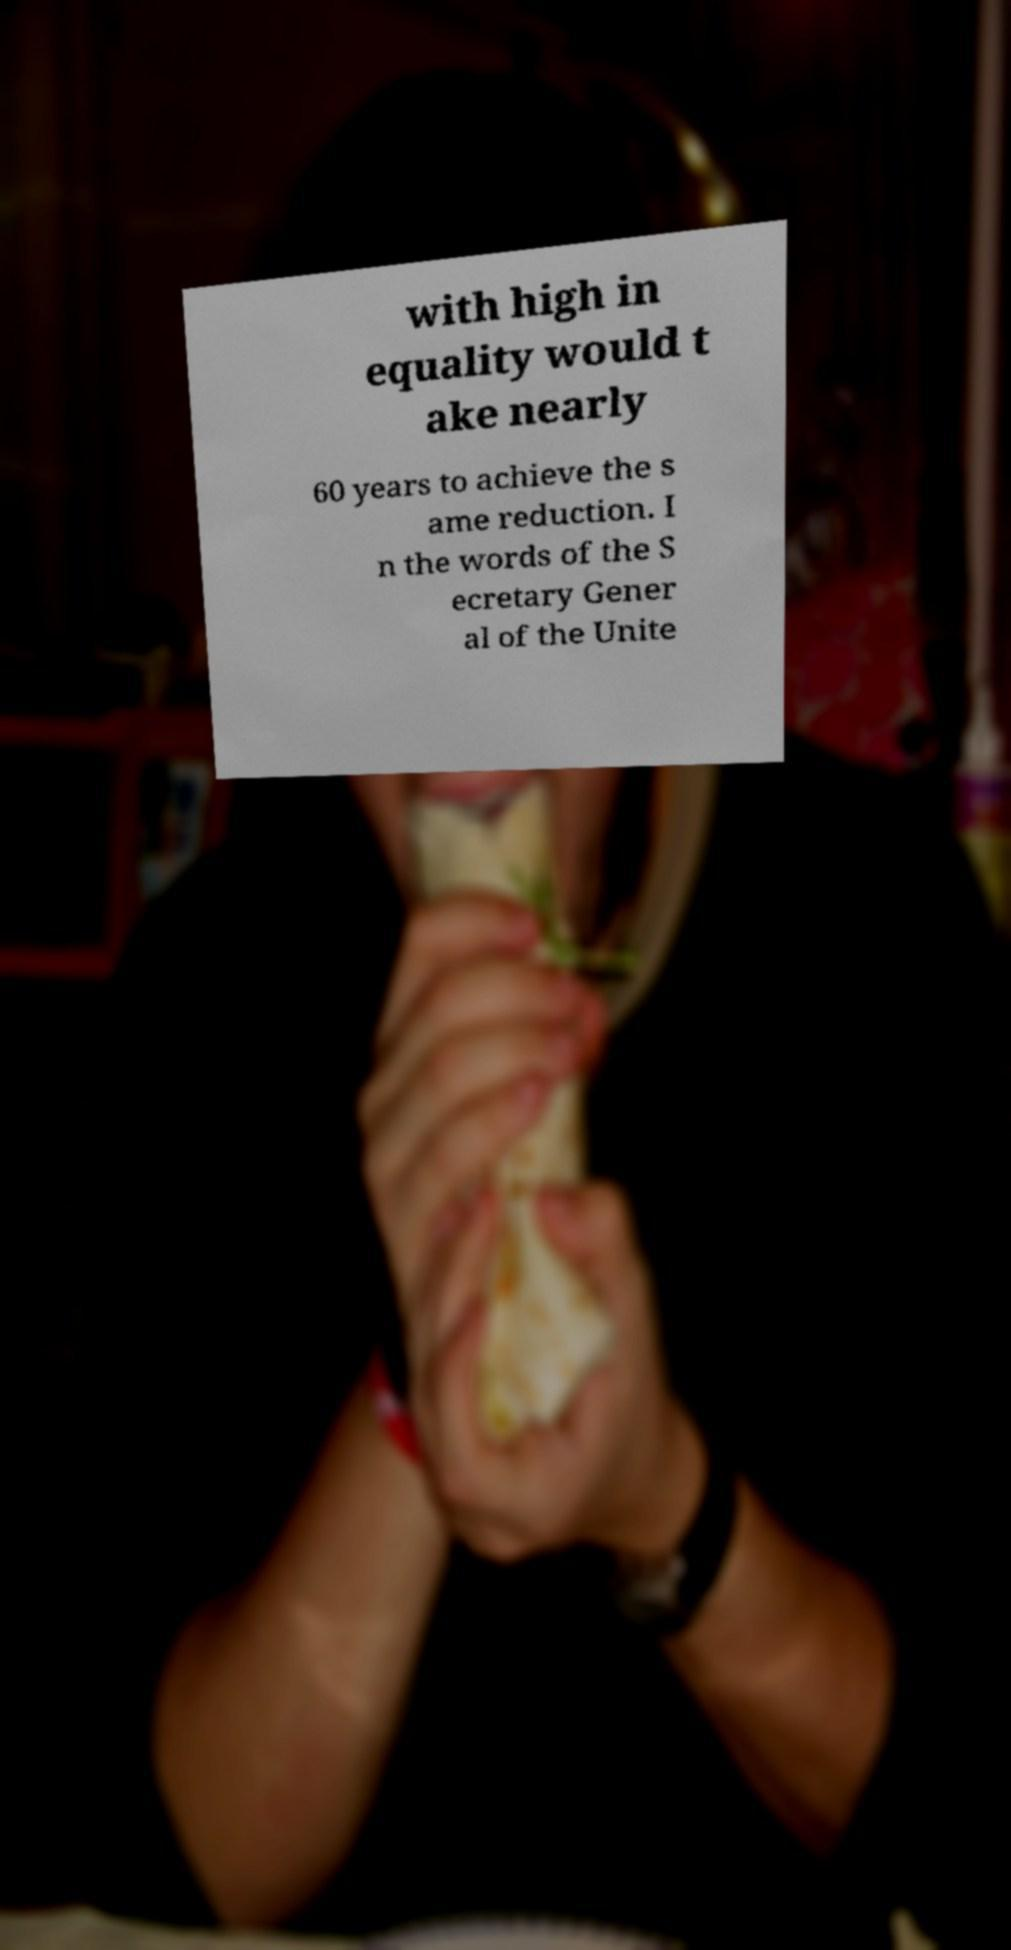Could you extract and type out the text from this image? with high in equality would t ake nearly 60 years to achieve the s ame reduction. I n the words of the S ecretary Gener al of the Unite 